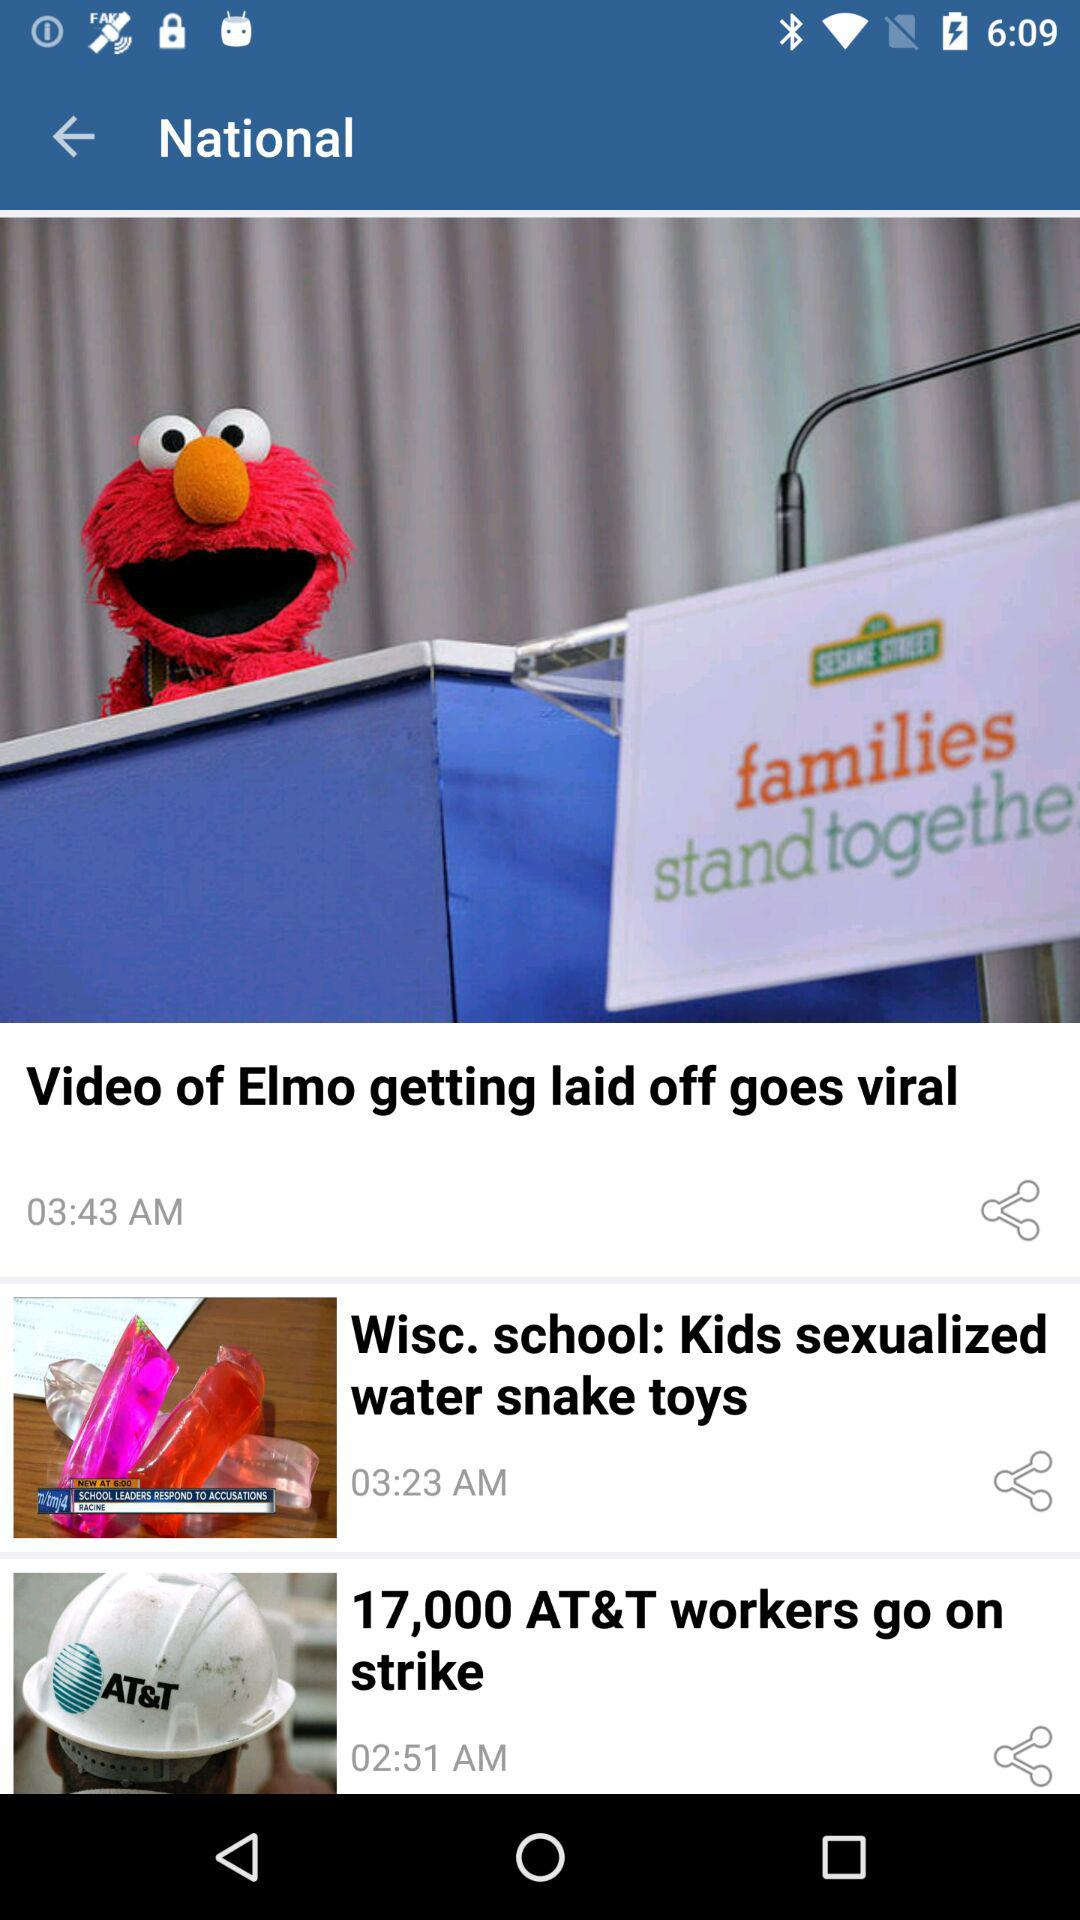At what time was the news "Video of Elmo getting laid off goes viral" posted? The news "Video of Elmo getting laid off goes viral" was posted at 3:43 AM. 